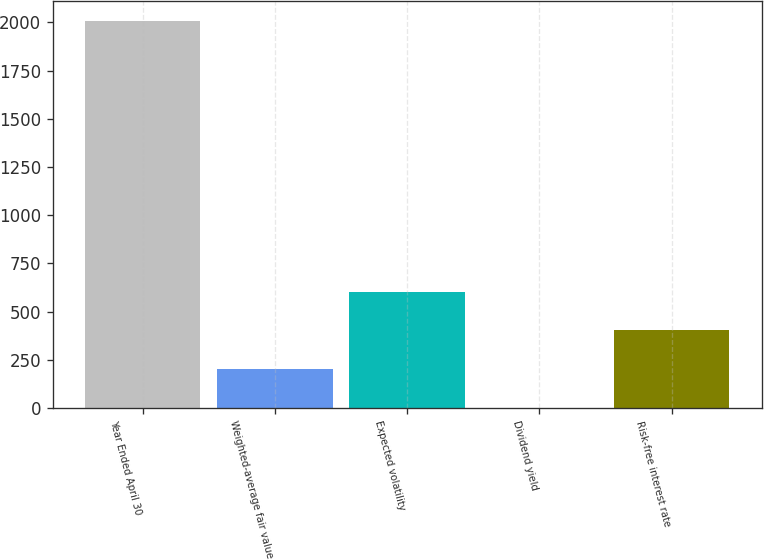Convert chart. <chart><loc_0><loc_0><loc_500><loc_500><bar_chart><fcel>Year Ended April 30<fcel>Weighted-average fair value<fcel>Expected volatility<fcel>Dividend yield<fcel>Risk-free interest rate<nl><fcel>2008<fcel>203<fcel>604.12<fcel>2.44<fcel>403.56<nl></chart> 